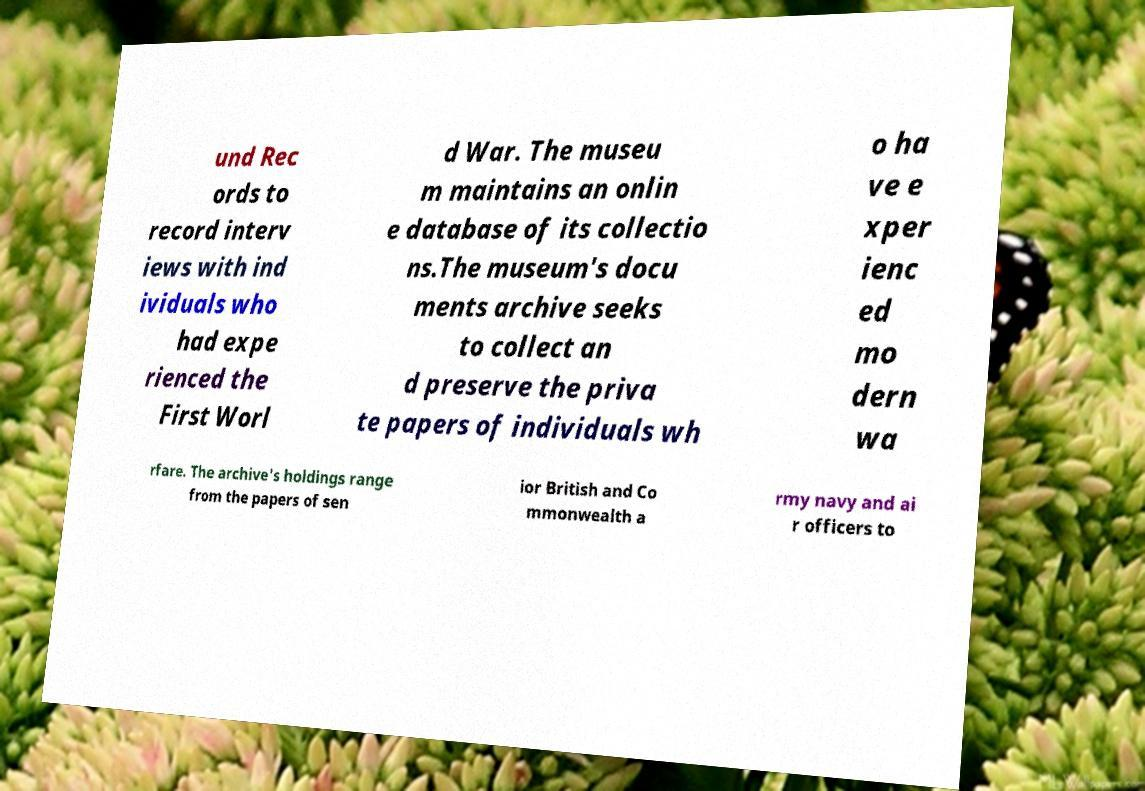I need the written content from this picture converted into text. Can you do that? und Rec ords to record interv iews with ind ividuals who had expe rienced the First Worl d War. The museu m maintains an onlin e database of its collectio ns.The museum's docu ments archive seeks to collect an d preserve the priva te papers of individuals wh o ha ve e xper ienc ed mo dern wa rfare. The archive's holdings range from the papers of sen ior British and Co mmonwealth a rmy navy and ai r officers to 